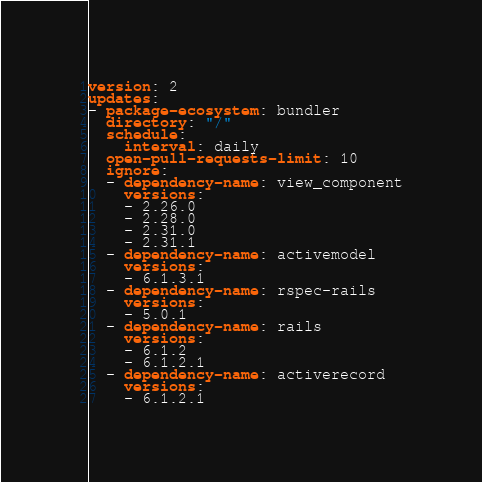Convert code to text. <code><loc_0><loc_0><loc_500><loc_500><_YAML_>version: 2
updates:
- package-ecosystem: bundler
  directory: "/"
  schedule:
    interval: daily
  open-pull-requests-limit: 10
  ignore:
  - dependency-name: view_component
    versions:
    - 2.26.0
    - 2.28.0
    - 2.31.0
    - 2.31.1
  - dependency-name: activemodel
    versions:
    - 6.1.3.1
  - dependency-name: rspec-rails
    versions:
    - 5.0.1
  - dependency-name: rails
    versions:
    - 6.1.2
    - 6.1.2.1
  - dependency-name: activerecord
    versions:
    - 6.1.2.1
</code> 